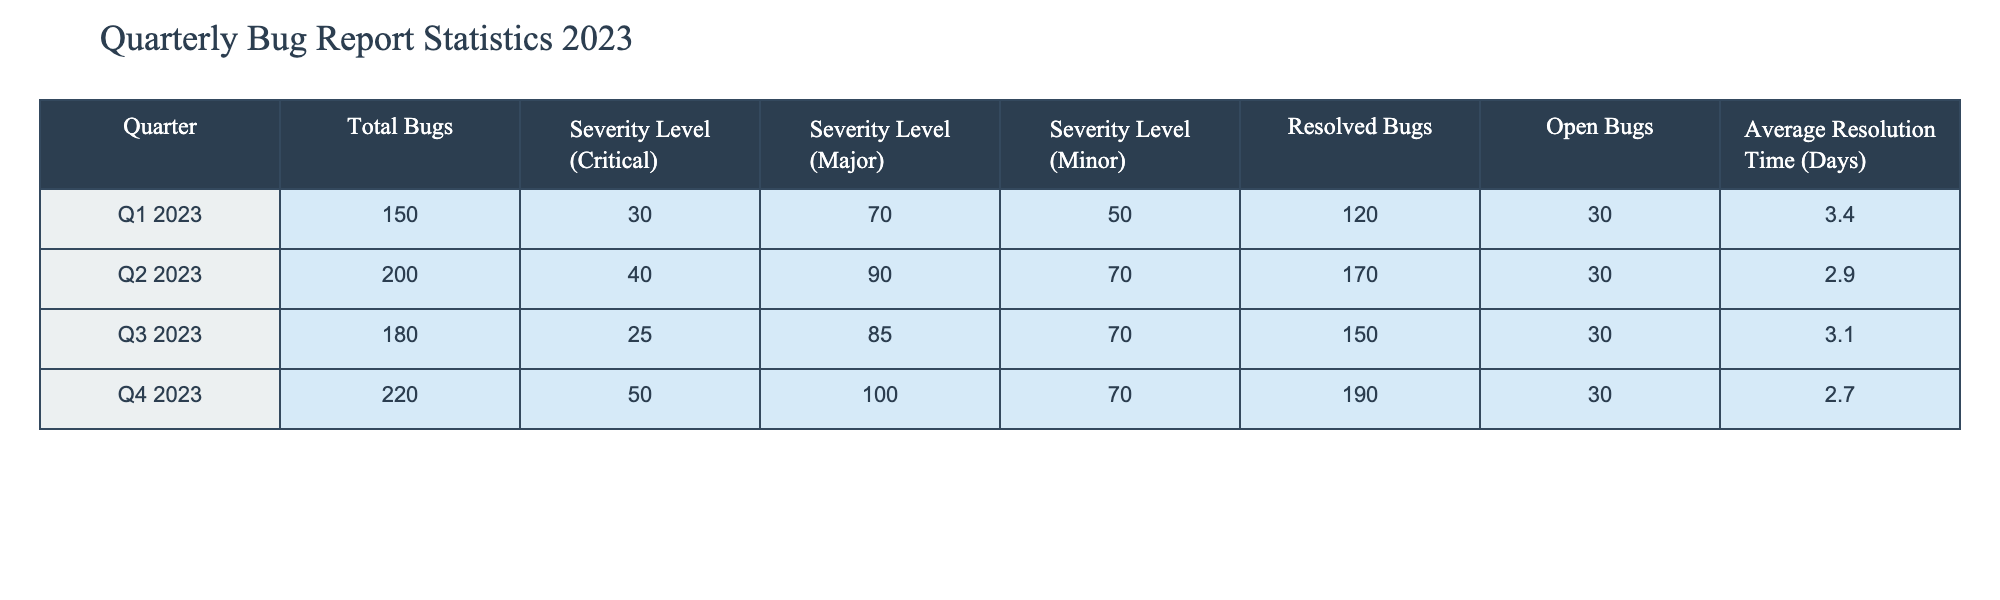What is the total number of bugs reported in Q2 2023? The table shows that the Total Bugs for Q2 2023 is listed directly. Referring to the Q2 2023 row in the Total Bugs column gives the value.
Answer: 200 What is the average resolution time for bugs in Q1 2023? The table provides the Average Resolution Time specifically for Q1 2023. By looking at the corresponding row, we can find the value directly.
Answer: 3.4 Which quarter had the highest number of resolved bugs? The Resolved Bugs column shows the following values: 120 (Q1), 170 (Q2), 150 (Q3), and 190 (Q4). Comparing these values, we can see that Q4 has the highest value.
Answer: Q4 2023 Is the number of open bugs consistent across all quarters? The Open Bugs column shows a consistent value of 30 for all quarters. Since there are no variations in this column, the answer is no.
Answer: Yes In Q3 2023, how many minor bugs were there? By checking the Minor column in the Q3 2023 row of the table, we see the number of Minor Bugs listed which can be directly read.
Answer: 70 What is the total number of critical bugs reported across all quarters? To find the total, we need to sum the Critical values from each quarter: 30 (Q1) + 40 (Q2) + 25 (Q3) + 50 (Q4) = 145. Thus, the total count can be derived from this addition.
Answer: 145 What percentage of bugs were resolved in Q2 2023? To find the percentage, we take the number of Resolved Bugs (170) and divide it by Total Bugs (200) and then multiply by 100: (170/200) * 100 = 85%. This gives the percentage of resolved bugs for Q2 2023.
Answer: 85% How many more major bugs were reported in Q2 than in Q3? By looking at the Major Bug counts: Q2 shows 90 and Q3 shows 85. To find the difference, we subtract: 90 - 85 = 5. Thus, this provides the answer to the difference in major bugs reported.
Answer: 5 Which quarter had the lowest average resolution time for bugs? The Average Resolution Time values for all quarters are: 3.4 (Q1), 2.9 (Q2), 3.1 (Q3), and 2.7 (Q4). The lowest value is 2.7, which corresponds to Q4 2023. Therefore, we find that Q4 has the lowest average resolution time.
Answer: Q4 2023 